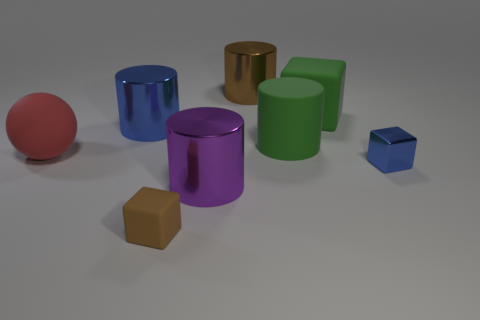What shape is the thing that is to the right of the brown cylinder and in front of the red matte ball? The shape to the right of the brown cylinder and in front of the red matte ball is a blue cube. It has a distinct, regular geometry with six equal square faces. 